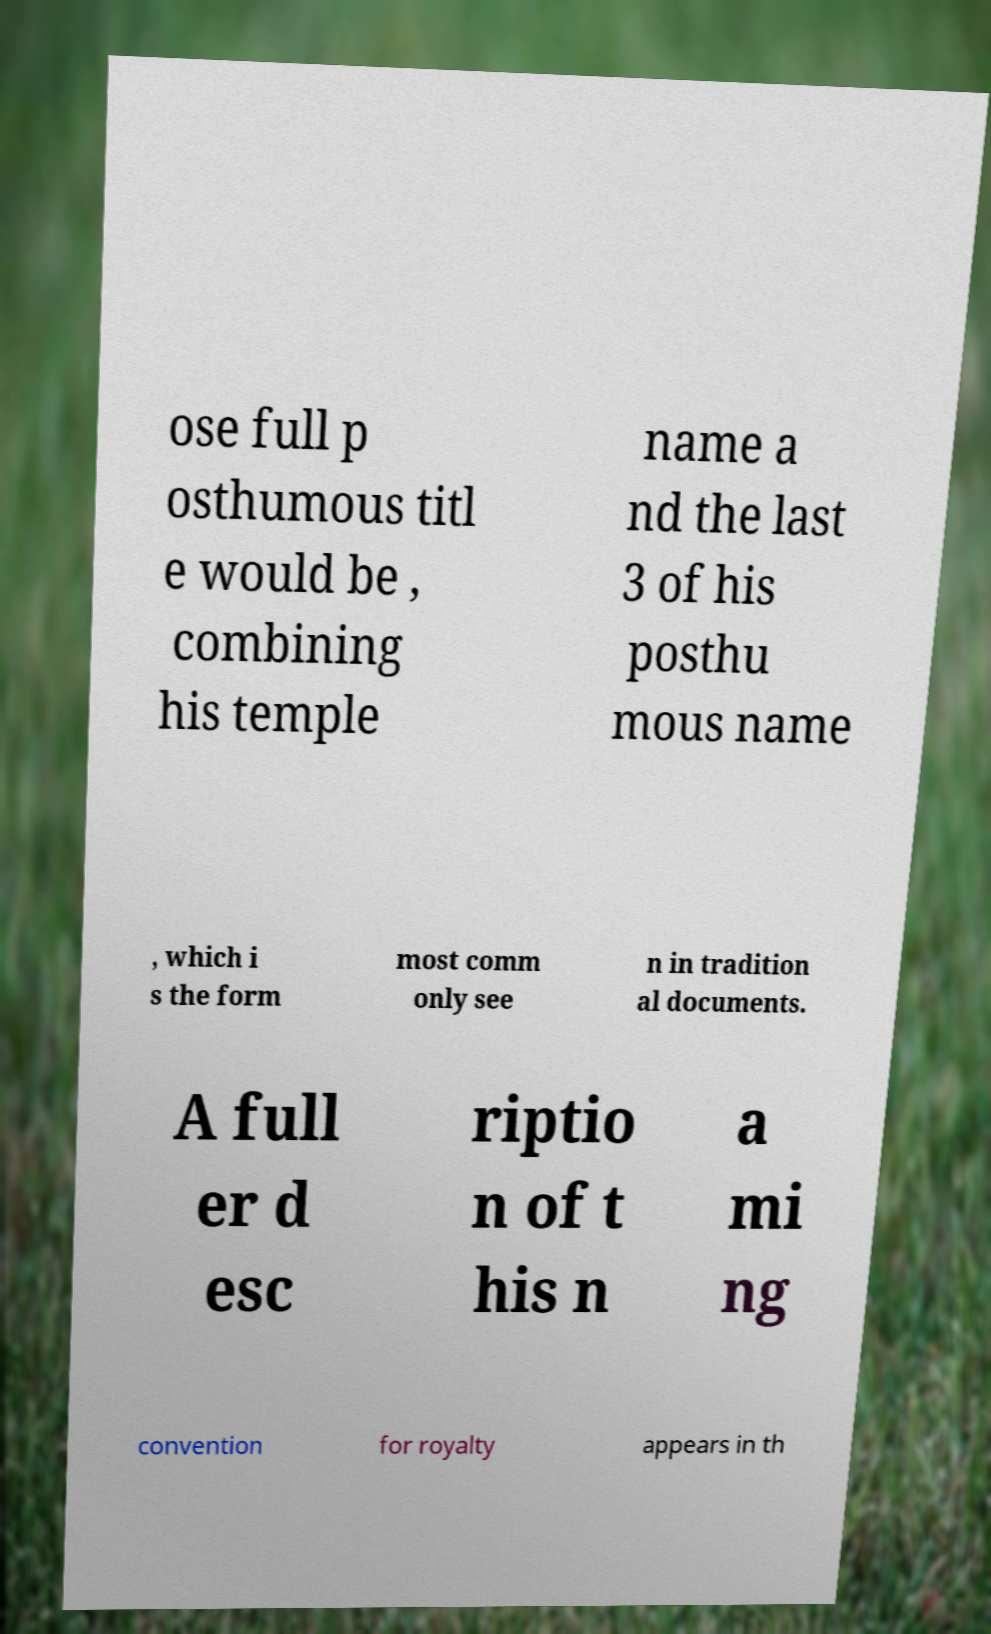There's text embedded in this image that I need extracted. Can you transcribe it verbatim? ose full p osthumous titl e would be , combining his temple name a nd the last 3 of his posthu mous name , which i s the form most comm only see n in tradition al documents. A full er d esc riptio n of t his n a mi ng convention for royalty appears in th 